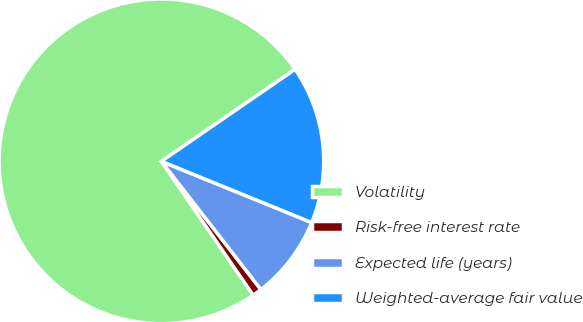Convert chart to OTSL. <chart><loc_0><loc_0><loc_500><loc_500><pie_chart><fcel>Volatility<fcel>Risk-free interest rate<fcel>Expected life (years)<fcel>Weighted-average fair value<nl><fcel>74.98%<fcel>0.94%<fcel>8.34%<fcel>15.75%<nl></chart> 